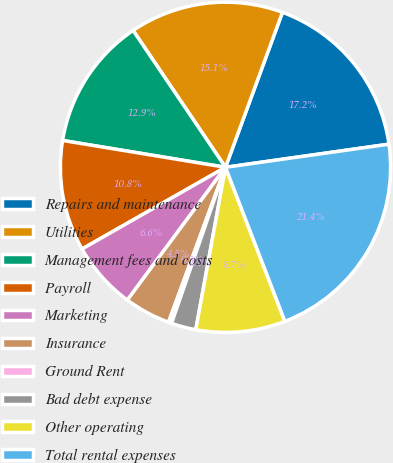<chart> <loc_0><loc_0><loc_500><loc_500><pie_chart><fcel>Repairs and maintenance<fcel>Utilities<fcel>Management fees and costs<fcel>Payroll<fcel>Marketing<fcel>Insurance<fcel>Ground Rent<fcel>Bad debt expense<fcel>Other operating<fcel>Total rental expenses<nl><fcel>17.16%<fcel>15.06%<fcel>12.95%<fcel>10.84%<fcel>6.63%<fcel>4.52%<fcel>0.31%<fcel>2.42%<fcel>8.74%<fcel>21.38%<nl></chart> 